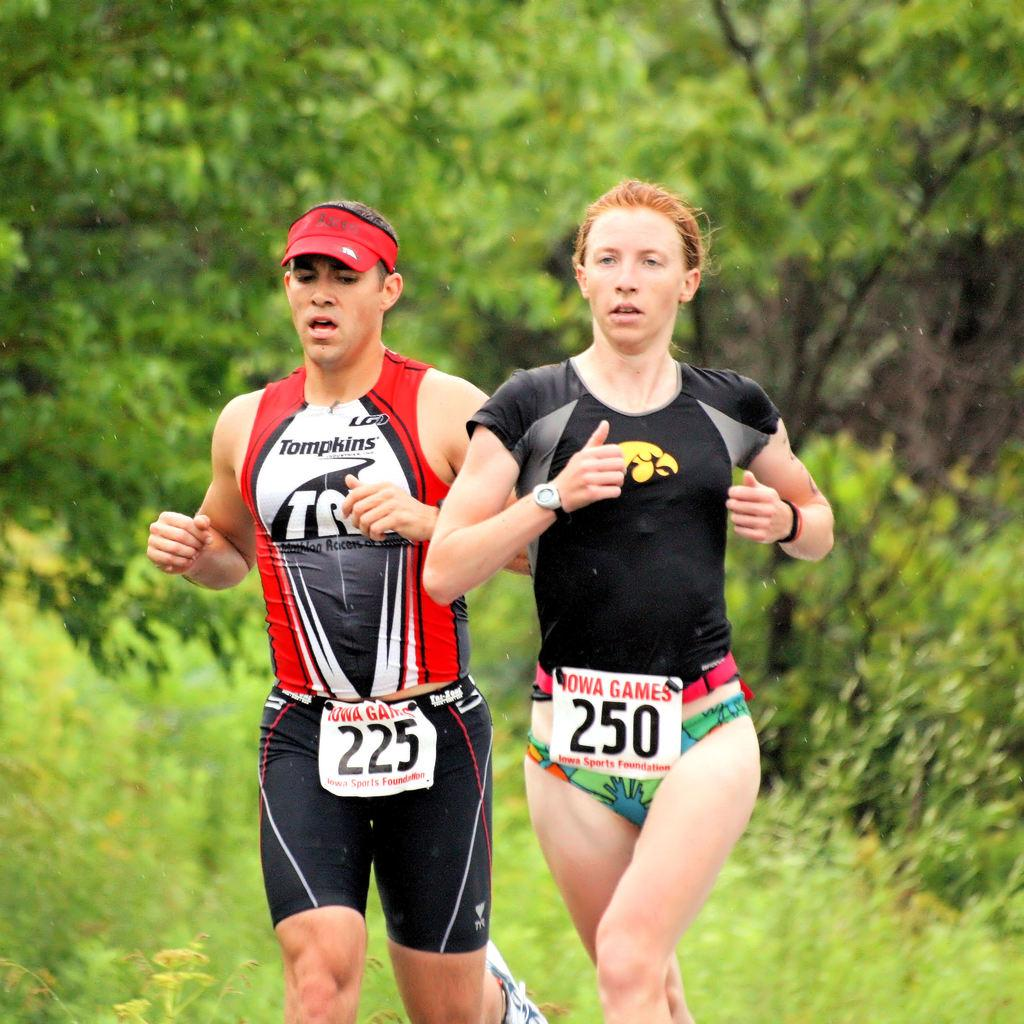<image>
Give a short and clear explanation of the subsequent image. Two people running in the Iowa Games are wearing the numbers 225 and 250. 